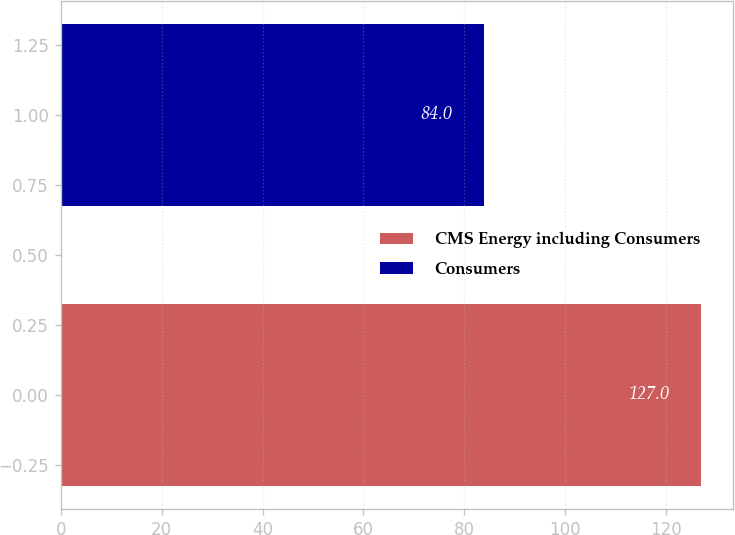Convert chart. <chart><loc_0><loc_0><loc_500><loc_500><bar_chart><fcel>CMS Energy including Consumers<fcel>Consumers<nl><fcel>127<fcel>84<nl></chart> 